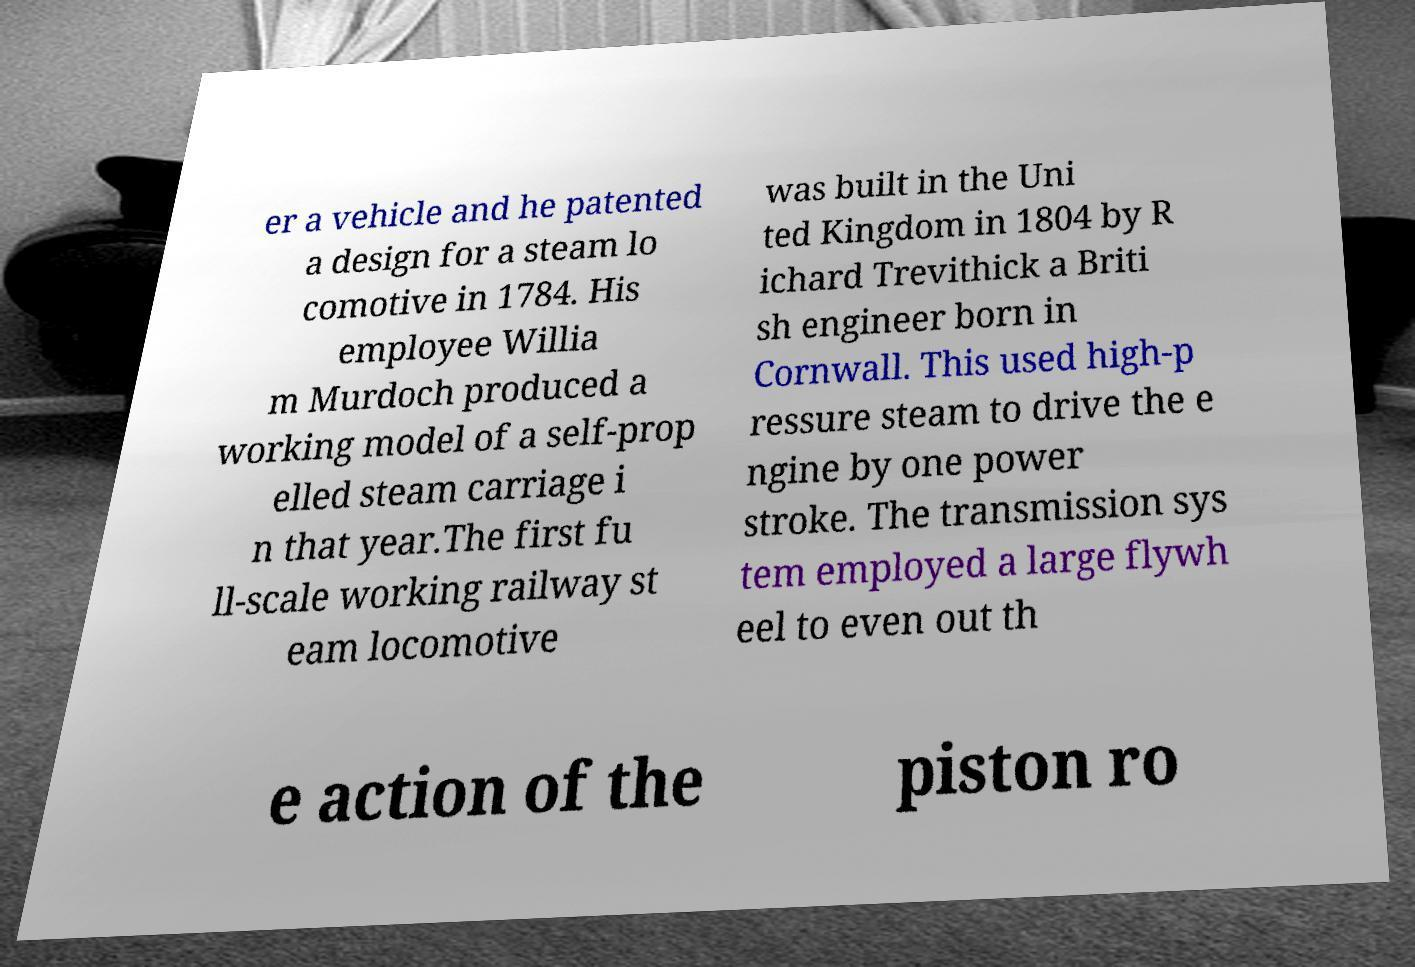I need the written content from this picture converted into text. Can you do that? er a vehicle and he patented a design for a steam lo comotive in 1784. His employee Willia m Murdoch produced a working model of a self-prop elled steam carriage i n that year.The first fu ll-scale working railway st eam locomotive was built in the Uni ted Kingdom in 1804 by R ichard Trevithick a Briti sh engineer born in Cornwall. This used high-p ressure steam to drive the e ngine by one power stroke. The transmission sys tem employed a large flywh eel to even out th e action of the piston ro 